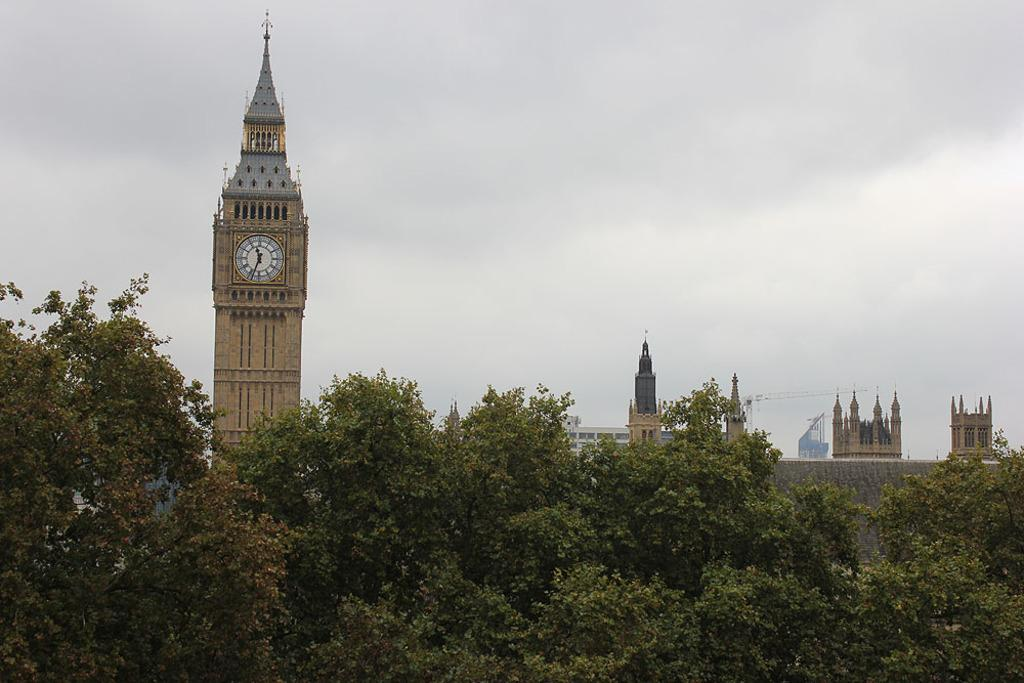What structures can be seen in the image? There are buildings in the image. What type of vegetation is present in front of the buildings? There are trees in front of the buildings. What part of the natural environment is visible in the image? The sky is visible in the background of the image. Where is the giraffe hiding in the image? There is no giraffe present in the image. What type of food is being served for lunch in the image? There is no reference to lunch or any food in the image. 